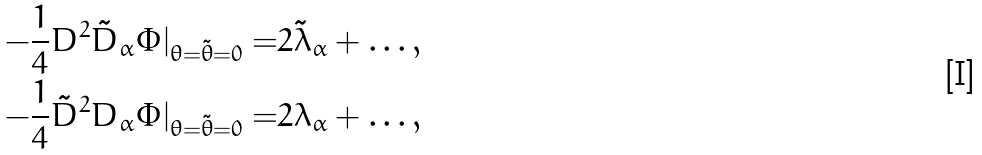<formula> <loc_0><loc_0><loc_500><loc_500>- \frac { 1 } { 4 } D ^ { 2 } \tilde { D } _ { \alpha } \Phi | _ { \theta = \tilde { \theta } = 0 } = & 2 \tilde { \lambda } _ { \alpha } + \dots , \\ - \frac { 1 } { 4 } \tilde { D } ^ { 2 } D _ { \alpha } \Phi | _ { \theta = \tilde { \theta } = 0 } = & 2 \lambda _ { \alpha } + \dots ,</formula> 